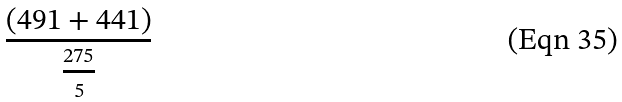Convert formula to latex. <formula><loc_0><loc_0><loc_500><loc_500>\frac { ( 4 9 1 + 4 4 1 ) } { \frac { 2 7 5 } { 5 } }</formula> 